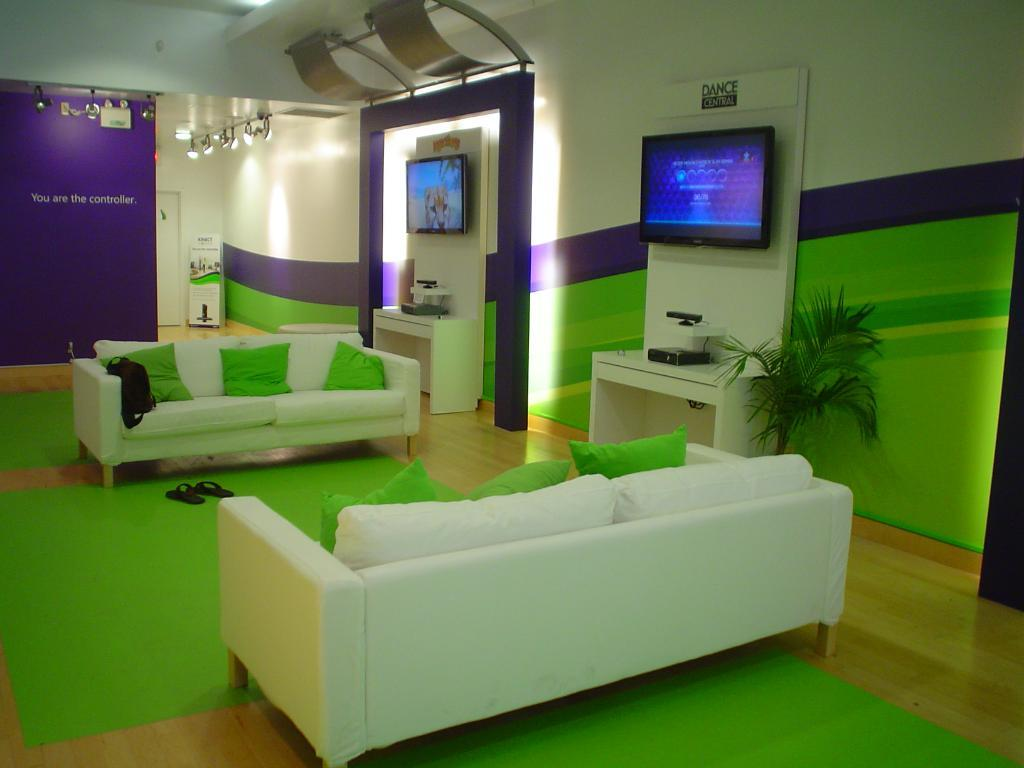How many sofas are in the image? There are two sofas in the image. What type of footwear can be seen in the image? There are slippers in the image. What electronic device is present in the image? There is a television in the image. What type of structure is visible in the image? There is a wall in the image. What type of vegetation is in the image? There is a plant in the image. What type of bone is visible on the wall in the image? There is no bone visible on the wall in the image. What type of coal is being used to fuel the television in the image? There is no coal being used to fuel the television in the image; it is powered by electricity. 